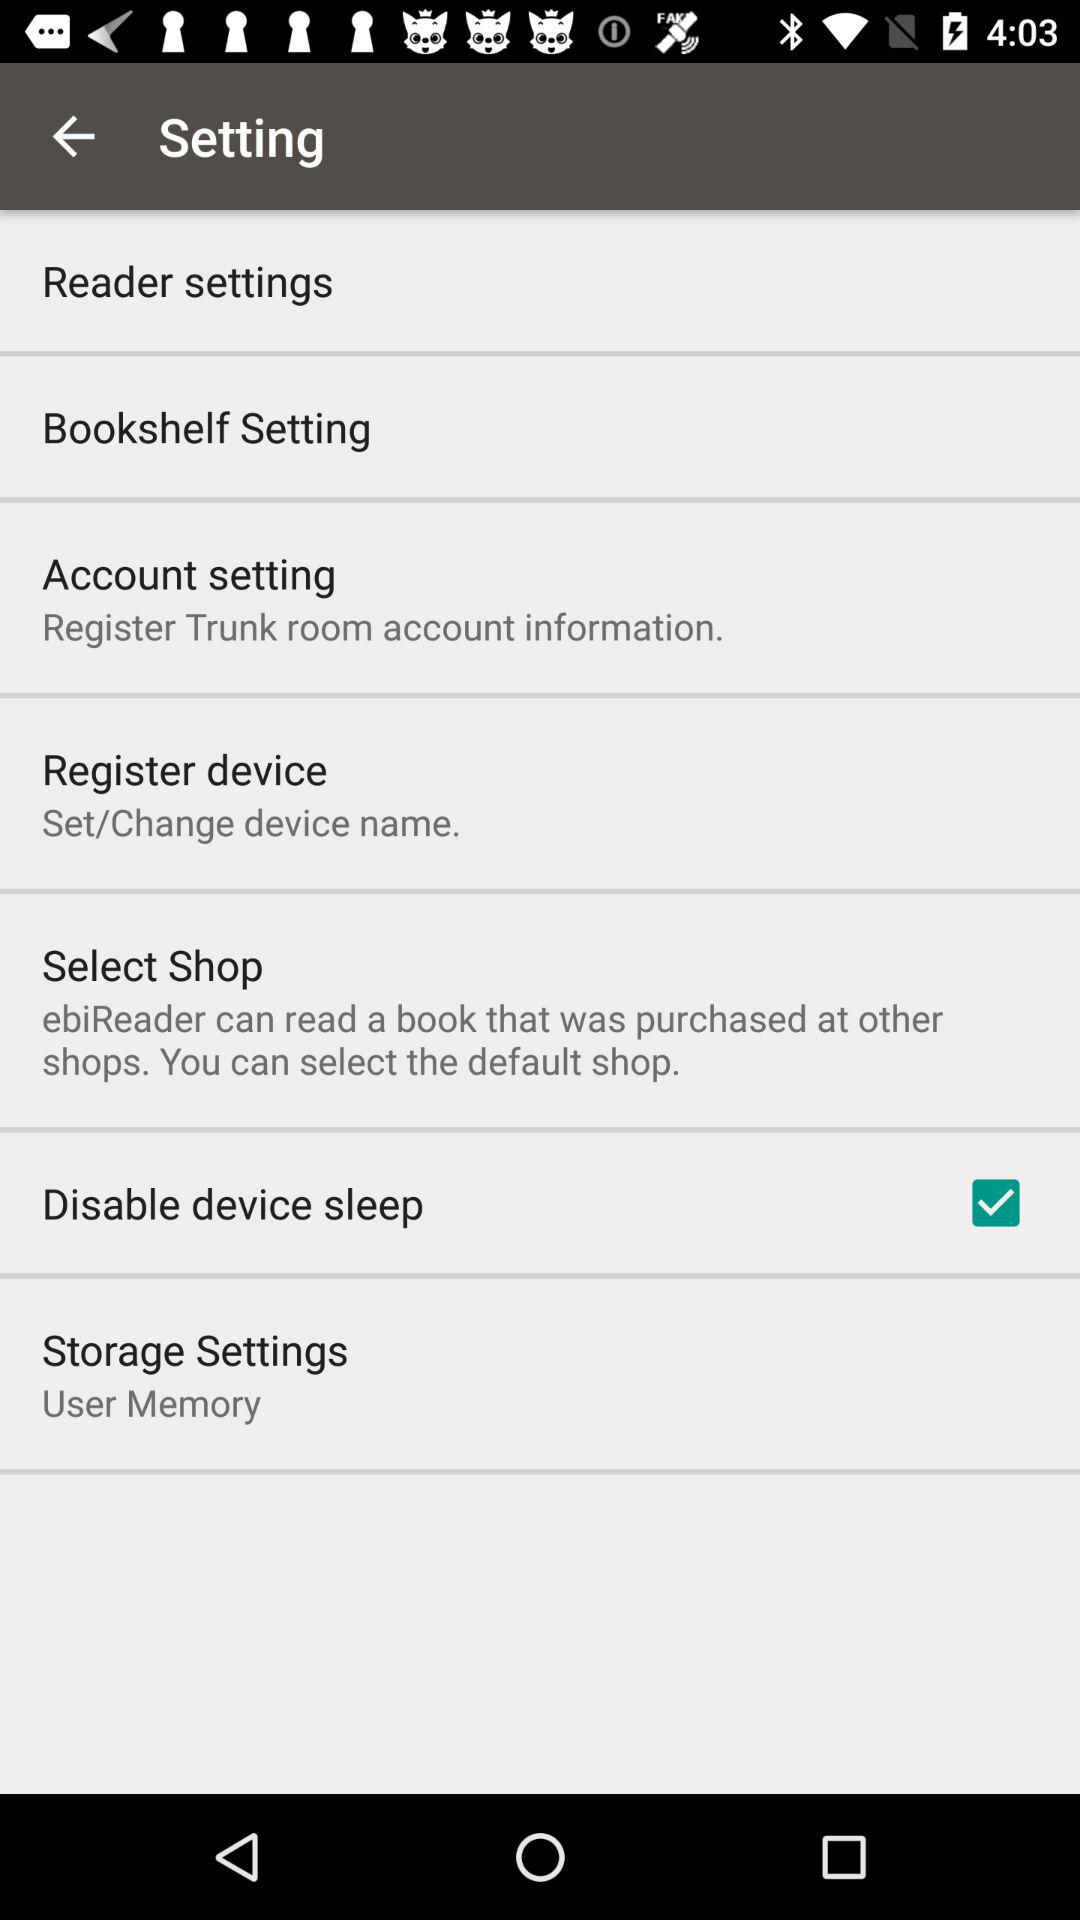What's the status of "Disable device sleep"? The status of "Disable device sleep" is "on". 